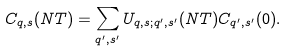<formula> <loc_0><loc_0><loc_500><loc_500>C _ { q , s } ( N T ) = \sum _ { q ^ { \prime } , s ^ { \prime } } U _ { q , s ; q ^ { \prime } , s ^ { \prime } } ( N T ) C _ { q ^ { \prime } , s ^ { \prime } } ( 0 ) .</formula> 